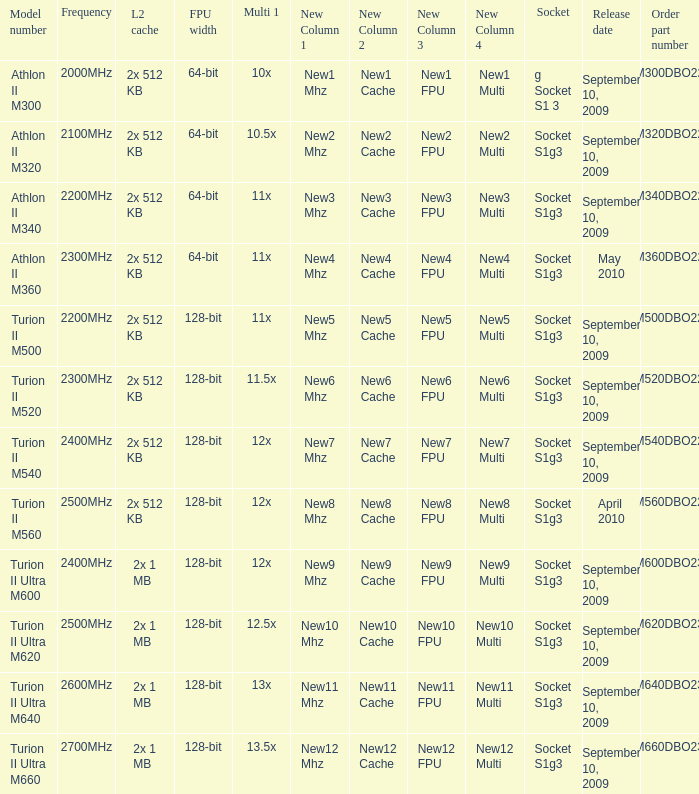What is the release date of the 2x 512 kb L2 cache with a 11x multi 1, and a FPU width of 128-bit? September 10, 2009. 